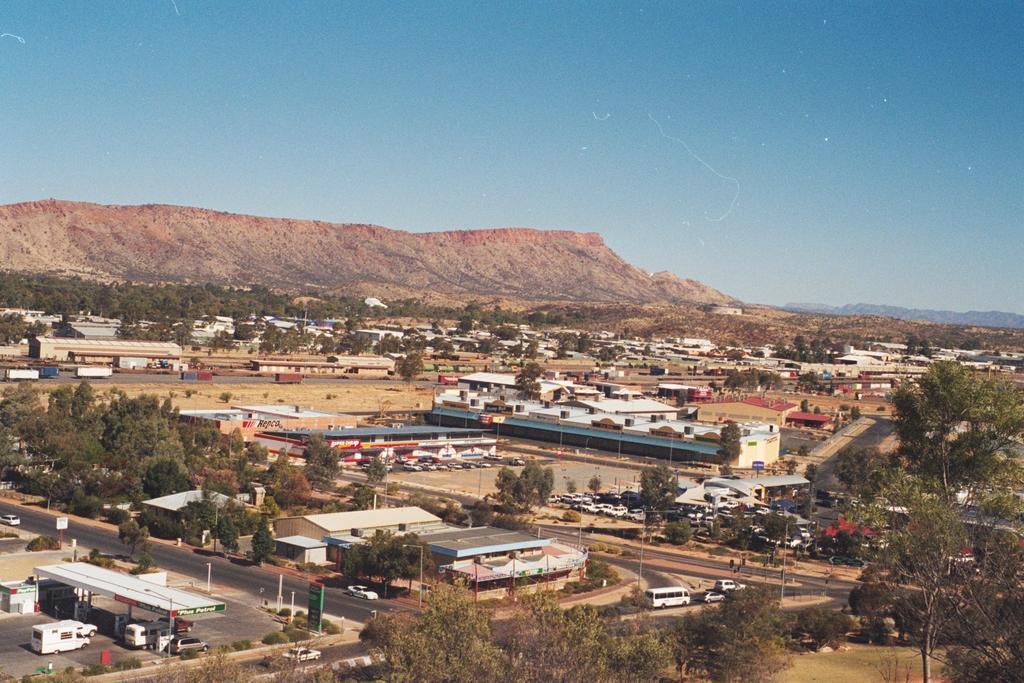In one or two sentences, can you explain what this image depicts? In this image I can see there are buildings and roads. On the road there are cars and a Truck. And there are boards, Poles, Trees, Plants and a mountain. There is a shed. And at the top there is a sky. 